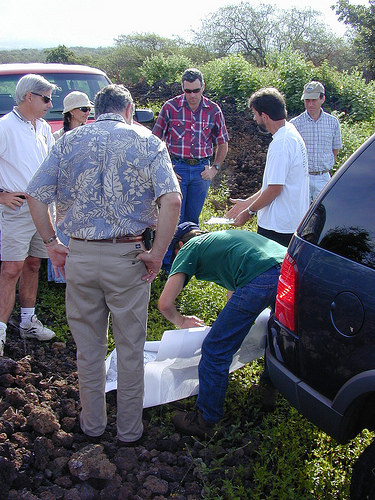<image>
Can you confirm if the hat is on the man? No. The hat is not positioned on the man. They may be near each other, but the hat is not supported by or resting on top of the man. 